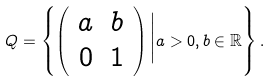<formula> <loc_0><loc_0><loc_500><loc_500>Q = \left \{ \left ( \begin{array} { c c } a & b \\ 0 & 1 \end{array} \right ) \Big | a > 0 , b \in \mathbb { R } \right \} .</formula> 